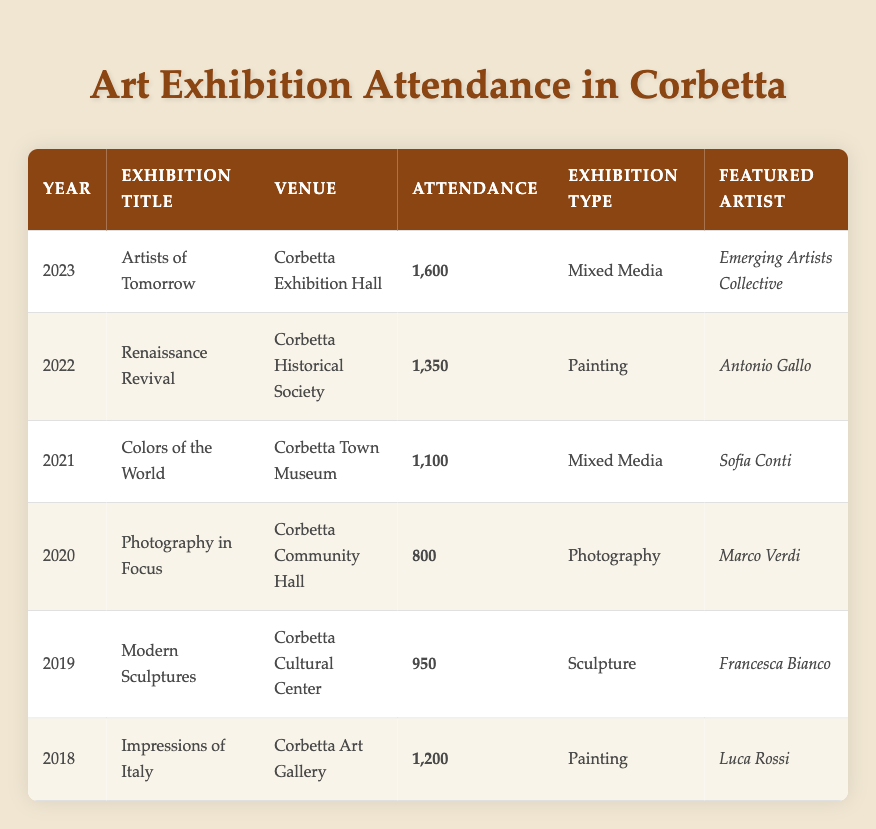What was the attendance for the "Renaissance Revival" exhibition? The "Renaissance Revival" exhibition took place in 2022, and the attendance listed in the table is 1,350.
Answer: 1,350 Which exhibition had the highest attendance? By comparing the attendance figures from all the exhibitions, the "Artists of Tomorrow" exhibition in 2023 had the highest attendance at 1,600.
Answer: 1,600 How many exhibitions were held in Corbetta from 2018 to 2023? The table lists a total of six exhibitions held in Corbetta from 2018 to 2023, one for each year in this range.
Answer: 6 What is the average attendance for the exhibitions listed? To find the average, sum the attendances: (1,200 + 950 + 800 + 1,100 + 1,350 + 1,600) = 6,000. Dividing by the number of exhibitions (6): 6,000 / 6 = 1,000.
Answer: 1,000 Was there any exhibition featuring mixed media in 2021? The table shows that "Colors of the World," which featured mixed media, took place in 2021, confirming that there was indeed an exhibition of this type that year.
Answer: Yes Which venue had the lowest attendance? The "Photography in Focus" exhibition in 2020, held at the Corbetta Community Hall, recorded the lowest attendance of 800 compared to the other exhibitions in the table.
Answer: 800 What is the difference in attendance between the highest and lowest attended exhibitions? The highest attendance was 1,600 for the "Artists of Tomorrow" exhibition in 2023, and the lowest was 800 for the "Photography in Focus" exhibition in 2020. The difference is 1,600 - 800 = 800.
Answer: 800 Did the attendance increase every year from 2018 to 2023? Reviewing the attendance data, the attendance did not increase every year; for example, the attendance decreased from 2019 (950) to 2020 (800) before it increased again.
Answer: No 